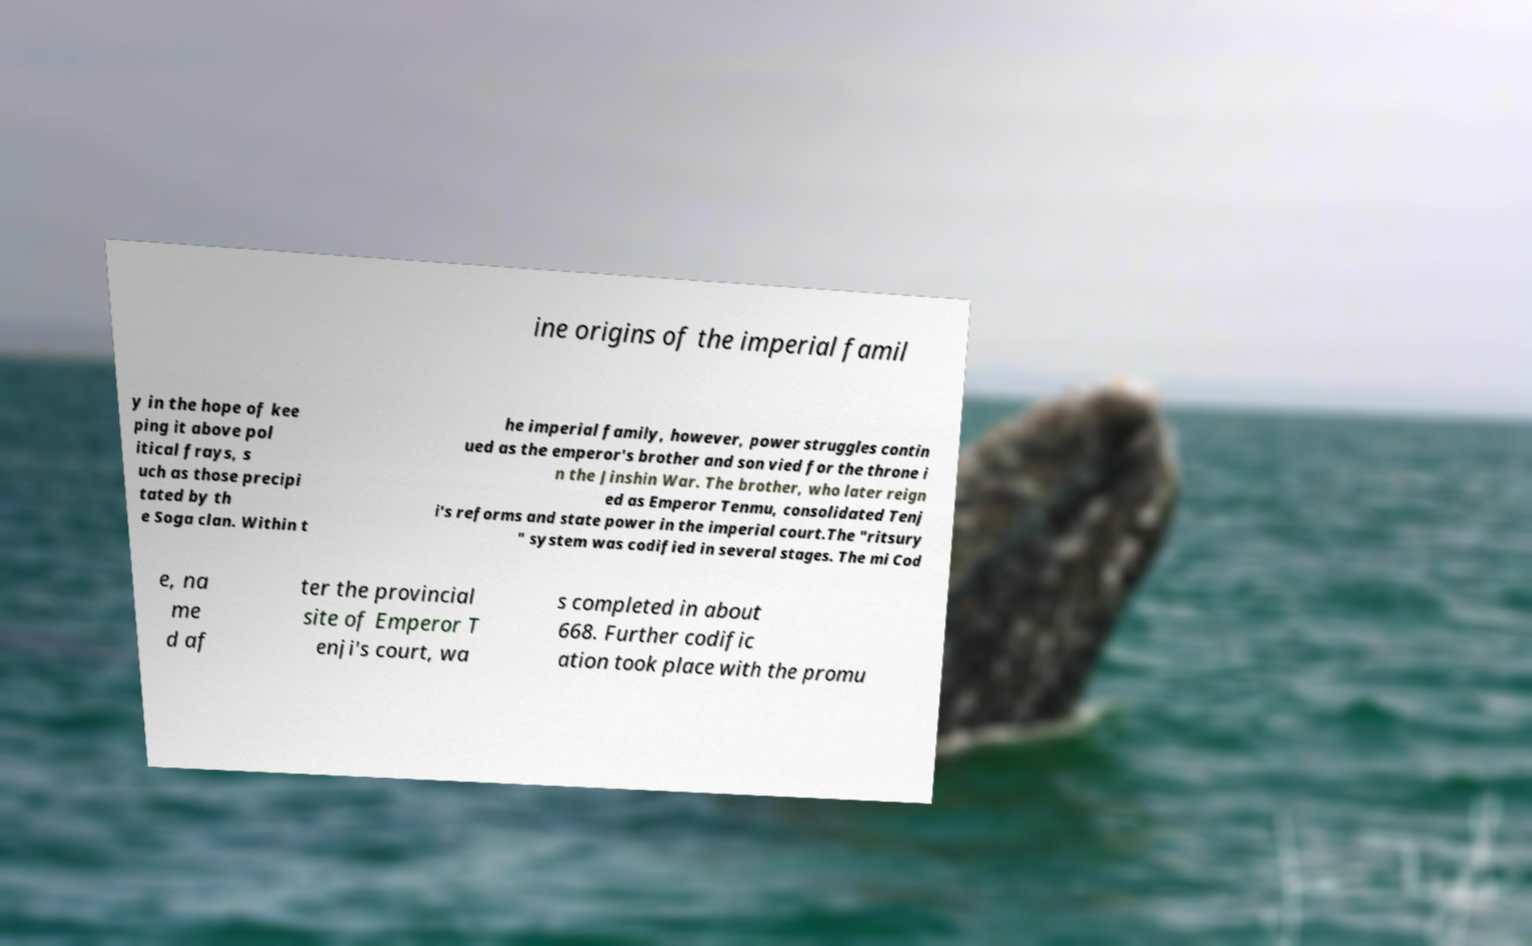What messages or text are displayed in this image? I need them in a readable, typed format. ine origins of the imperial famil y in the hope of kee ping it above pol itical frays, s uch as those precipi tated by th e Soga clan. Within t he imperial family, however, power struggles contin ued as the emperor's brother and son vied for the throne i n the Jinshin War. The brother, who later reign ed as Emperor Tenmu, consolidated Tenj i's reforms and state power in the imperial court.The "ritsury " system was codified in several stages. The mi Cod e, na me d af ter the provincial site of Emperor T enji's court, wa s completed in about 668. Further codific ation took place with the promu 